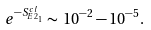<formula> <loc_0><loc_0><loc_500><loc_500>e ^ { - S ^ { c l } _ { E 2 _ { 1 } } } \sim \, 1 0 ^ { - 2 } - 1 0 ^ { - 5 } .</formula> 